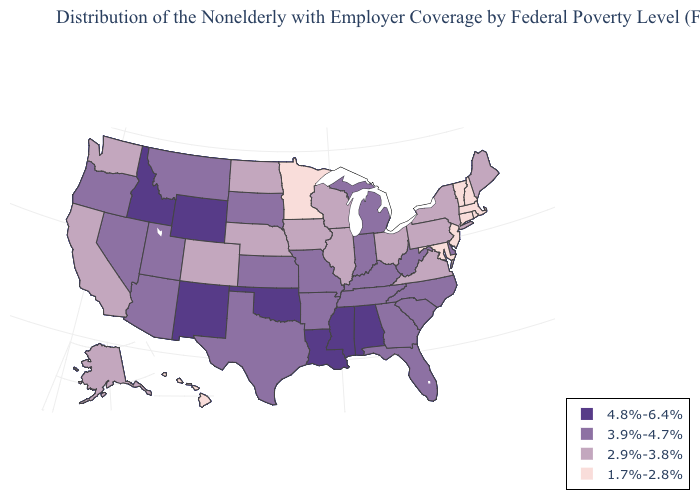What is the lowest value in the USA?
Quick response, please. 1.7%-2.8%. What is the value of Hawaii?
Answer briefly. 1.7%-2.8%. Name the states that have a value in the range 1.7%-2.8%?
Quick response, please. Connecticut, Hawaii, Maryland, Massachusetts, Minnesota, New Hampshire, New Jersey, Rhode Island, Vermont. Name the states that have a value in the range 4.8%-6.4%?
Answer briefly. Alabama, Idaho, Louisiana, Mississippi, New Mexico, Oklahoma, Wyoming. What is the highest value in the Northeast ?
Write a very short answer. 2.9%-3.8%. What is the value of Illinois?
Keep it brief. 2.9%-3.8%. What is the lowest value in the USA?
Be succinct. 1.7%-2.8%. Among the states that border West Virginia , does Kentucky have the lowest value?
Give a very brief answer. No. What is the highest value in the USA?
Be succinct. 4.8%-6.4%. Does Alabama have the highest value in the South?
Keep it brief. Yes. Does Virginia have a lower value than Indiana?
Be succinct. Yes. Among the states that border Vermont , does New Hampshire have the lowest value?
Give a very brief answer. Yes. What is the lowest value in the Northeast?
Give a very brief answer. 1.7%-2.8%. What is the value of Texas?
Keep it brief. 3.9%-4.7%. Which states have the lowest value in the USA?
Be succinct. Connecticut, Hawaii, Maryland, Massachusetts, Minnesota, New Hampshire, New Jersey, Rhode Island, Vermont. 